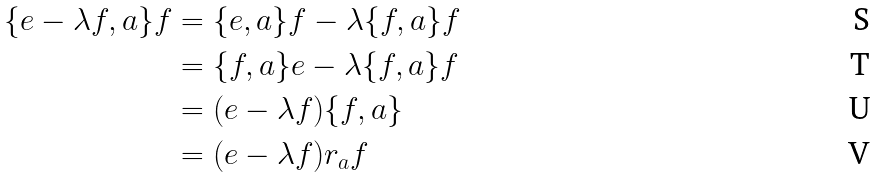<formula> <loc_0><loc_0><loc_500><loc_500>\{ e - \lambda f , a \} f & = \{ e , a \} f - \lambda \{ f , a \} f \\ & = \{ f , a \} e - \lambda \{ f , a \} f \\ & = ( e - \lambda f ) \{ f , a \} \\ & = ( e - \lambda f ) r _ { a } f</formula> 